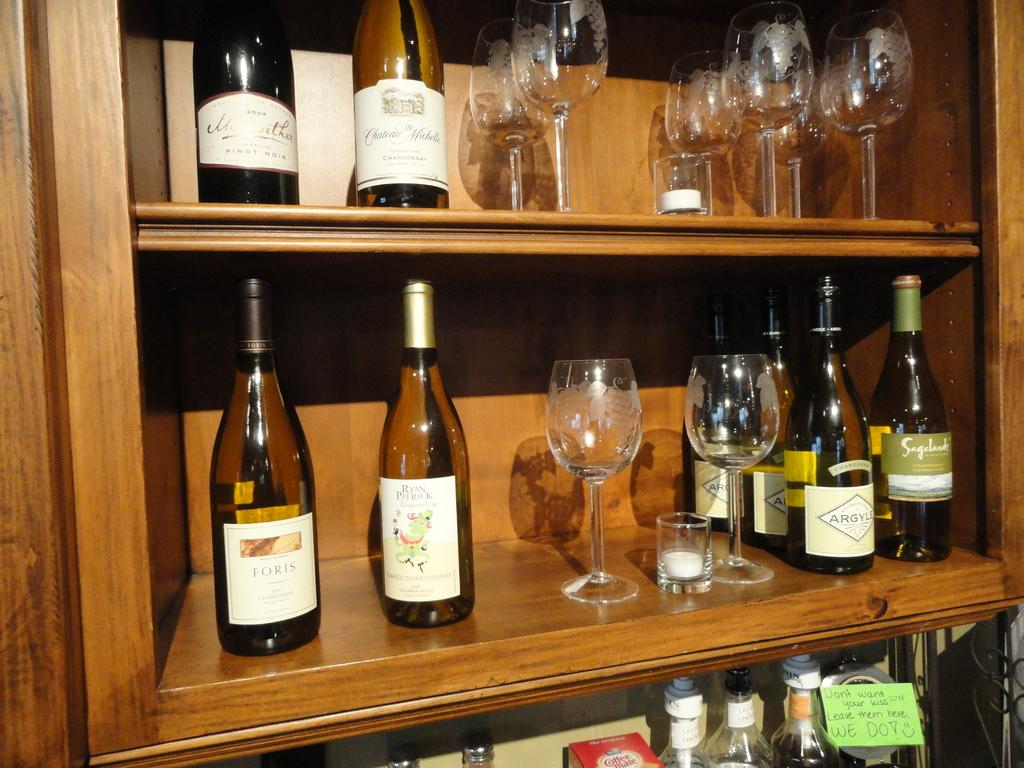What objects in the image are typically used for holding liquids? There are bottles and glasses in the image that are typically used for holding liquids. What type of fruit is visible in the image? There is no fruit present in the image. Is there a light bulb visible in the image? There is no light bulb present in the image. 